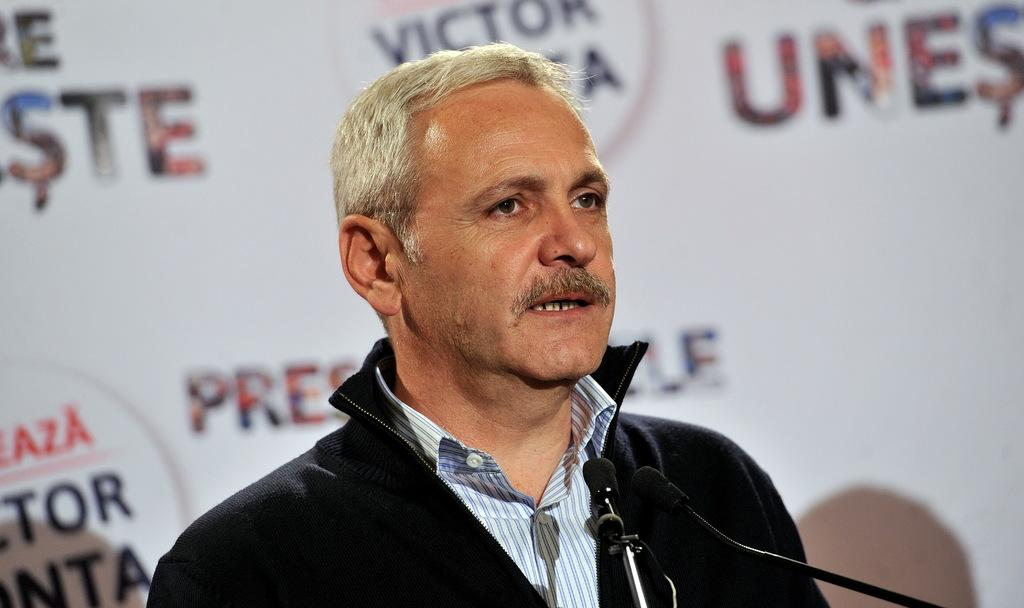Who or what is present in the image? There is a person in the image. What objects can be seen near the person? There are microphones in the image. What can be seen in the background of the image? There is a board in the background of the image. What type of fish can be seen swimming near the person in the image? There is no fish present in the image; it features a person and microphones. 